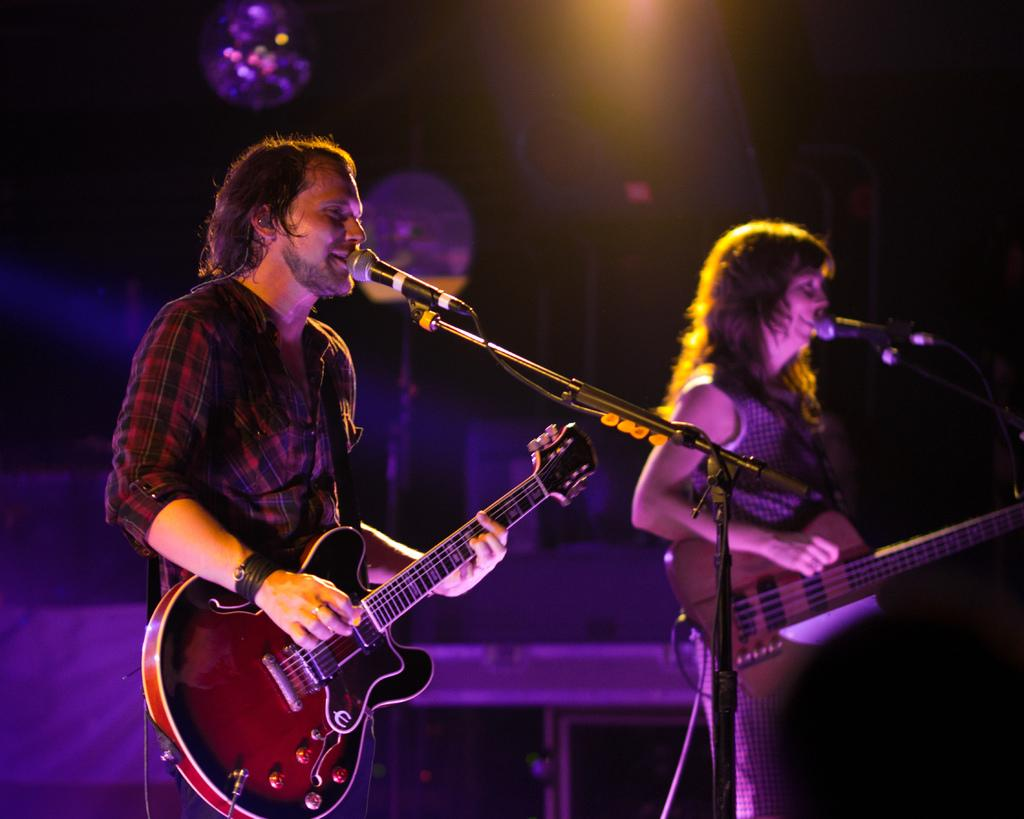What is the man in the image doing? The man is playing a guitar in the image. What is the man's position in relation to the microphone? The man is in front of a microphone in the image. What is the woman in the image doing? The woman is playing a guitar in the image. What is the woman's position in relation to the microphone? The woman is also in front of a microphone in the image. What can be seen in the background of the image? There are lights visible in the background of the image. What type of calculator is the man using while playing the guitar? There is no calculator present in the image; the man is playing a guitar and standing in front of a microphone. 